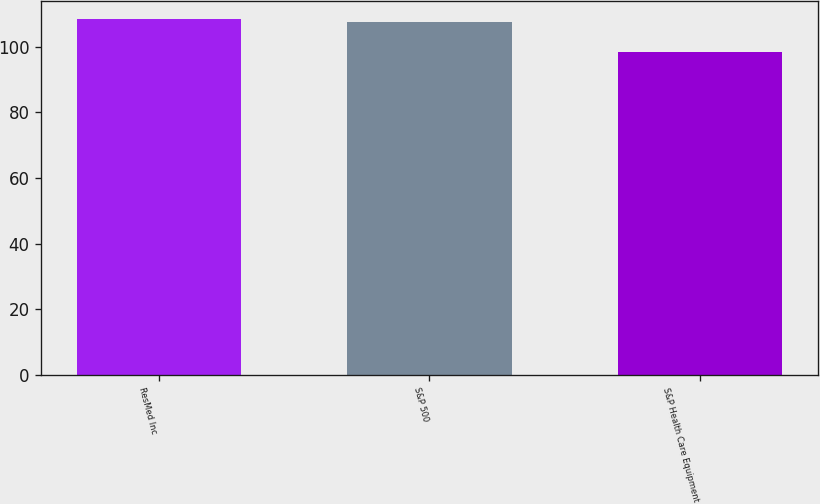Convert chart. <chart><loc_0><loc_0><loc_500><loc_500><bar_chart><fcel>ResMed Inc<fcel>S&P 500<fcel>S&P Health Care Equipment<nl><fcel>108.38<fcel>107.4<fcel>98.5<nl></chart> 